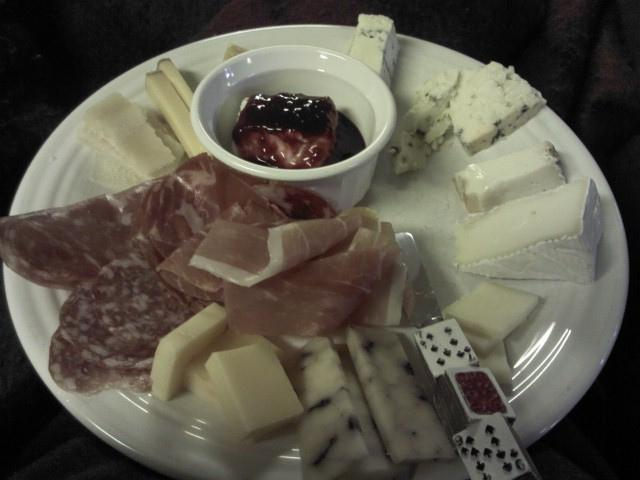What color is the back of the playing card printed cheese wedge? Please explain your reasoning. red. Playing cards are often red on one side. 